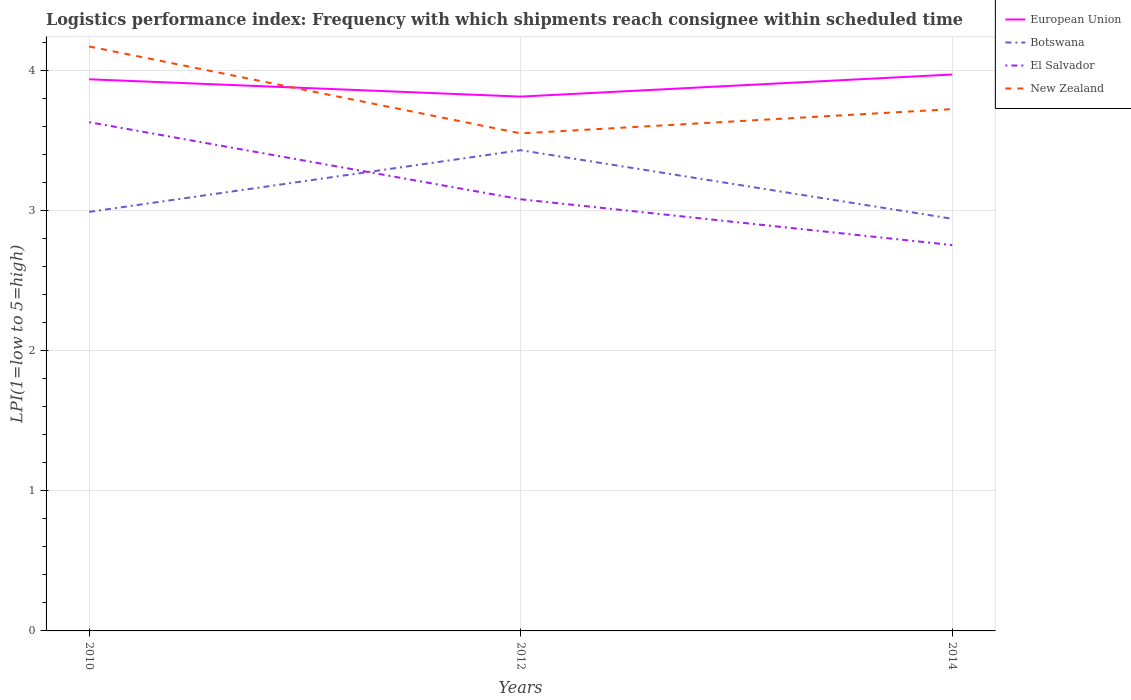How many different coloured lines are there?
Your answer should be very brief. 4. Does the line corresponding to Botswana intersect with the line corresponding to El Salvador?
Keep it short and to the point. Yes. Across all years, what is the maximum logistics performance index in El Salvador?
Ensure brevity in your answer.  2.75. In which year was the logistics performance index in New Zealand maximum?
Your response must be concise. 2012. What is the total logistics performance index in European Union in the graph?
Give a very brief answer. 0.12. What is the difference between the highest and the second highest logistics performance index in El Salvador?
Make the answer very short. 0.88. How many years are there in the graph?
Offer a very short reply. 3. Does the graph contain any zero values?
Keep it short and to the point. No. Does the graph contain grids?
Provide a short and direct response. Yes. Where does the legend appear in the graph?
Your answer should be very brief. Top right. How many legend labels are there?
Provide a succinct answer. 4. What is the title of the graph?
Give a very brief answer. Logistics performance index: Frequency with which shipments reach consignee within scheduled time. Does "Gabon" appear as one of the legend labels in the graph?
Keep it short and to the point. No. What is the label or title of the X-axis?
Ensure brevity in your answer.  Years. What is the label or title of the Y-axis?
Make the answer very short. LPI(1=low to 5=high). What is the LPI(1=low to 5=high) in European Union in 2010?
Offer a terse response. 3.94. What is the LPI(1=low to 5=high) in Botswana in 2010?
Keep it short and to the point. 2.99. What is the LPI(1=low to 5=high) of El Salvador in 2010?
Your answer should be compact. 3.63. What is the LPI(1=low to 5=high) in New Zealand in 2010?
Provide a succinct answer. 4.17. What is the LPI(1=low to 5=high) of European Union in 2012?
Ensure brevity in your answer.  3.81. What is the LPI(1=low to 5=high) in Botswana in 2012?
Your answer should be compact. 3.43. What is the LPI(1=low to 5=high) of El Salvador in 2012?
Keep it short and to the point. 3.08. What is the LPI(1=low to 5=high) of New Zealand in 2012?
Offer a very short reply. 3.55. What is the LPI(1=low to 5=high) in European Union in 2014?
Provide a short and direct response. 3.97. What is the LPI(1=low to 5=high) in Botswana in 2014?
Make the answer very short. 2.94. What is the LPI(1=low to 5=high) in El Salvador in 2014?
Make the answer very short. 2.75. What is the LPI(1=low to 5=high) in New Zealand in 2014?
Make the answer very short. 3.72. Across all years, what is the maximum LPI(1=low to 5=high) in European Union?
Ensure brevity in your answer.  3.97. Across all years, what is the maximum LPI(1=low to 5=high) in Botswana?
Your response must be concise. 3.43. Across all years, what is the maximum LPI(1=low to 5=high) in El Salvador?
Offer a very short reply. 3.63. Across all years, what is the maximum LPI(1=low to 5=high) in New Zealand?
Offer a terse response. 4.17. Across all years, what is the minimum LPI(1=low to 5=high) of European Union?
Offer a very short reply. 3.81. Across all years, what is the minimum LPI(1=low to 5=high) in Botswana?
Ensure brevity in your answer.  2.94. Across all years, what is the minimum LPI(1=low to 5=high) of El Salvador?
Provide a succinct answer. 2.75. Across all years, what is the minimum LPI(1=low to 5=high) in New Zealand?
Your response must be concise. 3.55. What is the total LPI(1=low to 5=high) in European Union in the graph?
Keep it short and to the point. 11.72. What is the total LPI(1=low to 5=high) in Botswana in the graph?
Your answer should be very brief. 9.36. What is the total LPI(1=low to 5=high) in El Salvador in the graph?
Your answer should be very brief. 9.46. What is the total LPI(1=low to 5=high) in New Zealand in the graph?
Your answer should be compact. 11.44. What is the difference between the LPI(1=low to 5=high) in European Union in 2010 and that in 2012?
Offer a terse response. 0.12. What is the difference between the LPI(1=low to 5=high) of Botswana in 2010 and that in 2012?
Your answer should be very brief. -0.44. What is the difference between the LPI(1=low to 5=high) of El Salvador in 2010 and that in 2012?
Your response must be concise. 0.55. What is the difference between the LPI(1=low to 5=high) in New Zealand in 2010 and that in 2012?
Your response must be concise. 0.62. What is the difference between the LPI(1=low to 5=high) in European Union in 2010 and that in 2014?
Offer a very short reply. -0.03. What is the difference between the LPI(1=low to 5=high) of Botswana in 2010 and that in 2014?
Offer a very short reply. 0.05. What is the difference between the LPI(1=low to 5=high) of El Salvador in 2010 and that in 2014?
Your response must be concise. 0.88. What is the difference between the LPI(1=low to 5=high) in New Zealand in 2010 and that in 2014?
Offer a terse response. 0.45. What is the difference between the LPI(1=low to 5=high) in European Union in 2012 and that in 2014?
Provide a succinct answer. -0.16. What is the difference between the LPI(1=low to 5=high) in Botswana in 2012 and that in 2014?
Your answer should be compact. 0.49. What is the difference between the LPI(1=low to 5=high) of El Salvador in 2012 and that in 2014?
Keep it short and to the point. 0.33. What is the difference between the LPI(1=low to 5=high) of New Zealand in 2012 and that in 2014?
Give a very brief answer. -0.17. What is the difference between the LPI(1=low to 5=high) of European Union in 2010 and the LPI(1=low to 5=high) of Botswana in 2012?
Provide a succinct answer. 0.51. What is the difference between the LPI(1=low to 5=high) of European Union in 2010 and the LPI(1=low to 5=high) of El Salvador in 2012?
Offer a terse response. 0.86. What is the difference between the LPI(1=low to 5=high) in European Union in 2010 and the LPI(1=low to 5=high) in New Zealand in 2012?
Your response must be concise. 0.39. What is the difference between the LPI(1=low to 5=high) of Botswana in 2010 and the LPI(1=low to 5=high) of El Salvador in 2012?
Make the answer very short. -0.09. What is the difference between the LPI(1=low to 5=high) in Botswana in 2010 and the LPI(1=low to 5=high) in New Zealand in 2012?
Your response must be concise. -0.56. What is the difference between the LPI(1=low to 5=high) of El Salvador in 2010 and the LPI(1=low to 5=high) of New Zealand in 2012?
Provide a succinct answer. 0.08. What is the difference between the LPI(1=low to 5=high) in European Union in 2010 and the LPI(1=low to 5=high) in Botswana in 2014?
Offer a terse response. 1. What is the difference between the LPI(1=low to 5=high) in European Union in 2010 and the LPI(1=low to 5=high) in El Salvador in 2014?
Give a very brief answer. 1.18. What is the difference between the LPI(1=low to 5=high) in European Union in 2010 and the LPI(1=low to 5=high) in New Zealand in 2014?
Your response must be concise. 0.21. What is the difference between the LPI(1=low to 5=high) in Botswana in 2010 and the LPI(1=low to 5=high) in El Salvador in 2014?
Provide a succinct answer. 0.24. What is the difference between the LPI(1=low to 5=high) of Botswana in 2010 and the LPI(1=low to 5=high) of New Zealand in 2014?
Offer a very short reply. -0.73. What is the difference between the LPI(1=low to 5=high) in El Salvador in 2010 and the LPI(1=low to 5=high) in New Zealand in 2014?
Your answer should be compact. -0.09. What is the difference between the LPI(1=low to 5=high) of European Union in 2012 and the LPI(1=low to 5=high) of Botswana in 2014?
Offer a very short reply. 0.87. What is the difference between the LPI(1=low to 5=high) in European Union in 2012 and the LPI(1=low to 5=high) in El Salvador in 2014?
Your answer should be very brief. 1.06. What is the difference between the LPI(1=low to 5=high) in European Union in 2012 and the LPI(1=low to 5=high) in New Zealand in 2014?
Keep it short and to the point. 0.09. What is the difference between the LPI(1=low to 5=high) of Botswana in 2012 and the LPI(1=low to 5=high) of El Salvador in 2014?
Make the answer very short. 0.68. What is the difference between the LPI(1=low to 5=high) in Botswana in 2012 and the LPI(1=low to 5=high) in New Zealand in 2014?
Keep it short and to the point. -0.29. What is the difference between the LPI(1=low to 5=high) of El Salvador in 2012 and the LPI(1=low to 5=high) of New Zealand in 2014?
Ensure brevity in your answer.  -0.64. What is the average LPI(1=low to 5=high) of European Union per year?
Ensure brevity in your answer.  3.91. What is the average LPI(1=low to 5=high) of Botswana per year?
Your answer should be very brief. 3.12. What is the average LPI(1=low to 5=high) in El Salvador per year?
Provide a succinct answer. 3.15. What is the average LPI(1=low to 5=high) in New Zealand per year?
Ensure brevity in your answer.  3.81. In the year 2010, what is the difference between the LPI(1=low to 5=high) in European Union and LPI(1=low to 5=high) in Botswana?
Offer a very short reply. 0.95. In the year 2010, what is the difference between the LPI(1=low to 5=high) in European Union and LPI(1=low to 5=high) in El Salvador?
Provide a short and direct response. 0.31. In the year 2010, what is the difference between the LPI(1=low to 5=high) in European Union and LPI(1=low to 5=high) in New Zealand?
Offer a very short reply. -0.23. In the year 2010, what is the difference between the LPI(1=low to 5=high) of Botswana and LPI(1=low to 5=high) of El Salvador?
Your answer should be very brief. -0.64. In the year 2010, what is the difference between the LPI(1=low to 5=high) of Botswana and LPI(1=low to 5=high) of New Zealand?
Your answer should be compact. -1.18. In the year 2010, what is the difference between the LPI(1=low to 5=high) of El Salvador and LPI(1=low to 5=high) of New Zealand?
Your answer should be compact. -0.54. In the year 2012, what is the difference between the LPI(1=low to 5=high) of European Union and LPI(1=low to 5=high) of Botswana?
Provide a succinct answer. 0.38. In the year 2012, what is the difference between the LPI(1=low to 5=high) in European Union and LPI(1=low to 5=high) in El Salvador?
Offer a terse response. 0.73. In the year 2012, what is the difference between the LPI(1=low to 5=high) in European Union and LPI(1=low to 5=high) in New Zealand?
Give a very brief answer. 0.26. In the year 2012, what is the difference between the LPI(1=low to 5=high) of Botswana and LPI(1=low to 5=high) of New Zealand?
Your answer should be compact. -0.12. In the year 2012, what is the difference between the LPI(1=low to 5=high) of El Salvador and LPI(1=low to 5=high) of New Zealand?
Your answer should be compact. -0.47. In the year 2014, what is the difference between the LPI(1=low to 5=high) of European Union and LPI(1=low to 5=high) of Botswana?
Your answer should be compact. 1.03. In the year 2014, what is the difference between the LPI(1=low to 5=high) of European Union and LPI(1=low to 5=high) of El Salvador?
Provide a short and direct response. 1.22. In the year 2014, what is the difference between the LPI(1=low to 5=high) of European Union and LPI(1=low to 5=high) of New Zealand?
Give a very brief answer. 0.25. In the year 2014, what is the difference between the LPI(1=low to 5=high) of Botswana and LPI(1=low to 5=high) of El Salvador?
Provide a succinct answer. 0.19. In the year 2014, what is the difference between the LPI(1=low to 5=high) of Botswana and LPI(1=low to 5=high) of New Zealand?
Provide a succinct answer. -0.78. In the year 2014, what is the difference between the LPI(1=low to 5=high) of El Salvador and LPI(1=low to 5=high) of New Zealand?
Offer a terse response. -0.97. What is the ratio of the LPI(1=low to 5=high) of European Union in 2010 to that in 2012?
Ensure brevity in your answer.  1.03. What is the ratio of the LPI(1=low to 5=high) of Botswana in 2010 to that in 2012?
Keep it short and to the point. 0.87. What is the ratio of the LPI(1=low to 5=high) of El Salvador in 2010 to that in 2012?
Offer a very short reply. 1.18. What is the ratio of the LPI(1=low to 5=high) in New Zealand in 2010 to that in 2012?
Make the answer very short. 1.17. What is the ratio of the LPI(1=low to 5=high) of Botswana in 2010 to that in 2014?
Make the answer very short. 1.02. What is the ratio of the LPI(1=low to 5=high) in El Salvador in 2010 to that in 2014?
Provide a short and direct response. 1.32. What is the ratio of the LPI(1=low to 5=high) of New Zealand in 2010 to that in 2014?
Keep it short and to the point. 1.12. What is the ratio of the LPI(1=low to 5=high) of European Union in 2012 to that in 2014?
Your response must be concise. 0.96. What is the ratio of the LPI(1=low to 5=high) of Botswana in 2012 to that in 2014?
Your answer should be compact. 1.17. What is the ratio of the LPI(1=low to 5=high) in El Salvador in 2012 to that in 2014?
Ensure brevity in your answer.  1.12. What is the ratio of the LPI(1=low to 5=high) in New Zealand in 2012 to that in 2014?
Provide a succinct answer. 0.95. What is the difference between the highest and the second highest LPI(1=low to 5=high) of European Union?
Your answer should be compact. 0.03. What is the difference between the highest and the second highest LPI(1=low to 5=high) of Botswana?
Your response must be concise. 0.44. What is the difference between the highest and the second highest LPI(1=low to 5=high) in El Salvador?
Ensure brevity in your answer.  0.55. What is the difference between the highest and the second highest LPI(1=low to 5=high) of New Zealand?
Your answer should be very brief. 0.45. What is the difference between the highest and the lowest LPI(1=low to 5=high) of European Union?
Make the answer very short. 0.16. What is the difference between the highest and the lowest LPI(1=low to 5=high) of Botswana?
Provide a short and direct response. 0.49. What is the difference between the highest and the lowest LPI(1=low to 5=high) of El Salvador?
Give a very brief answer. 0.88. What is the difference between the highest and the lowest LPI(1=low to 5=high) of New Zealand?
Provide a succinct answer. 0.62. 